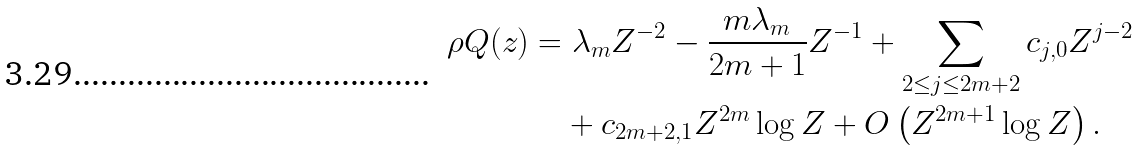Convert formula to latex. <formula><loc_0><loc_0><loc_500><loc_500>\rho Q ( z ) & = \lambda _ { m } Z ^ { - 2 } - \frac { m \lambda _ { m } } { 2 m + 1 } Z ^ { - 1 } + \sum _ { 2 \leq j \leq 2 m + 2 } c _ { j , 0 } Z ^ { j - 2 } \\ & \quad + c _ { 2 m + 2 , 1 } Z ^ { 2 m } \log Z + O \left ( Z ^ { 2 m + 1 } \log Z \right ) .</formula> 